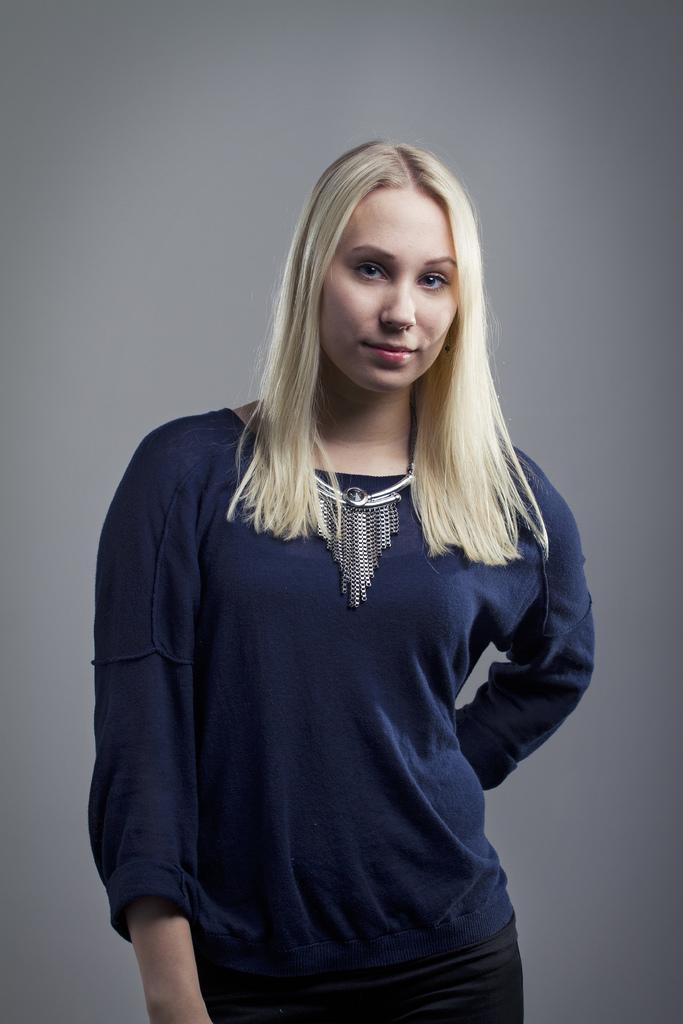Describe this image in one or two sentences. In this picture there is a woman who is wearing t-shirt and necklace. She is smiling and standing near to the wall. 